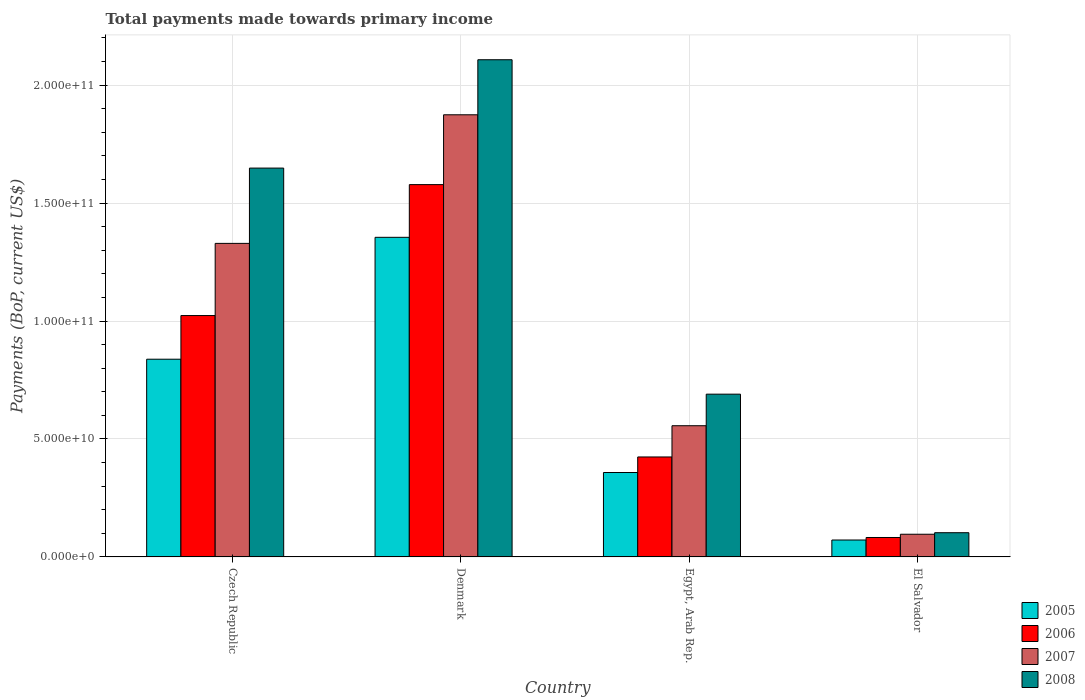How many groups of bars are there?
Your response must be concise. 4. How many bars are there on the 2nd tick from the right?
Your answer should be compact. 4. What is the label of the 1st group of bars from the left?
Offer a terse response. Czech Republic. What is the total payments made towards primary income in 2008 in Egypt, Arab Rep.?
Your answer should be compact. 6.90e+1. Across all countries, what is the maximum total payments made towards primary income in 2008?
Provide a short and direct response. 2.11e+11. Across all countries, what is the minimum total payments made towards primary income in 2008?
Ensure brevity in your answer.  1.03e+1. In which country was the total payments made towards primary income in 2007 maximum?
Make the answer very short. Denmark. In which country was the total payments made towards primary income in 2007 minimum?
Provide a short and direct response. El Salvador. What is the total total payments made towards primary income in 2007 in the graph?
Provide a short and direct response. 3.86e+11. What is the difference between the total payments made towards primary income in 2007 in Czech Republic and that in Denmark?
Keep it short and to the point. -5.45e+1. What is the difference between the total payments made towards primary income in 2008 in Egypt, Arab Rep. and the total payments made towards primary income in 2006 in El Salvador?
Ensure brevity in your answer.  6.08e+1. What is the average total payments made towards primary income in 2007 per country?
Give a very brief answer. 9.64e+1. What is the difference between the total payments made towards primary income of/in 2006 and total payments made towards primary income of/in 2007 in Czech Republic?
Give a very brief answer. -3.06e+1. In how many countries, is the total payments made towards primary income in 2008 greater than 70000000000 US$?
Your answer should be very brief. 2. What is the ratio of the total payments made towards primary income in 2005 in Czech Republic to that in Egypt, Arab Rep.?
Your answer should be compact. 2.34. What is the difference between the highest and the second highest total payments made towards primary income in 2006?
Offer a very short reply. -1.15e+11. What is the difference between the highest and the lowest total payments made towards primary income in 2007?
Your answer should be very brief. 1.78e+11. Is it the case that in every country, the sum of the total payments made towards primary income in 2006 and total payments made towards primary income in 2007 is greater than the sum of total payments made towards primary income in 2008 and total payments made towards primary income in 2005?
Provide a succinct answer. No. Is it the case that in every country, the sum of the total payments made towards primary income in 2005 and total payments made towards primary income in 2008 is greater than the total payments made towards primary income in 2006?
Provide a short and direct response. Yes. How many bars are there?
Offer a very short reply. 16. Are all the bars in the graph horizontal?
Provide a succinct answer. No. What is the difference between two consecutive major ticks on the Y-axis?
Offer a terse response. 5.00e+1. How many legend labels are there?
Make the answer very short. 4. What is the title of the graph?
Give a very brief answer. Total payments made towards primary income. What is the label or title of the Y-axis?
Your response must be concise. Payments (BoP, current US$). What is the Payments (BoP, current US$) in 2005 in Czech Republic?
Offer a very short reply. 8.38e+1. What is the Payments (BoP, current US$) in 2006 in Czech Republic?
Keep it short and to the point. 1.02e+11. What is the Payments (BoP, current US$) in 2007 in Czech Republic?
Your answer should be compact. 1.33e+11. What is the Payments (BoP, current US$) in 2008 in Czech Republic?
Provide a succinct answer. 1.65e+11. What is the Payments (BoP, current US$) in 2005 in Denmark?
Your answer should be very brief. 1.35e+11. What is the Payments (BoP, current US$) in 2006 in Denmark?
Offer a terse response. 1.58e+11. What is the Payments (BoP, current US$) in 2007 in Denmark?
Offer a very short reply. 1.87e+11. What is the Payments (BoP, current US$) of 2008 in Denmark?
Provide a short and direct response. 2.11e+11. What is the Payments (BoP, current US$) of 2005 in Egypt, Arab Rep.?
Give a very brief answer. 3.58e+1. What is the Payments (BoP, current US$) of 2006 in Egypt, Arab Rep.?
Ensure brevity in your answer.  4.24e+1. What is the Payments (BoP, current US$) in 2007 in Egypt, Arab Rep.?
Your answer should be very brief. 5.56e+1. What is the Payments (BoP, current US$) of 2008 in Egypt, Arab Rep.?
Offer a terse response. 6.90e+1. What is the Payments (BoP, current US$) in 2005 in El Salvador?
Your response must be concise. 7.17e+09. What is the Payments (BoP, current US$) in 2006 in El Salvador?
Provide a succinct answer. 8.24e+09. What is the Payments (BoP, current US$) of 2007 in El Salvador?
Ensure brevity in your answer.  9.62e+09. What is the Payments (BoP, current US$) of 2008 in El Salvador?
Offer a terse response. 1.03e+1. Across all countries, what is the maximum Payments (BoP, current US$) in 2005?
Your answer should be very brief. 1.35e+11. Across all countries, what is the maximum Payments (BoP, current US$) of 2006?
Offer a very short reply. 1.58e+11. Across all countries, what is the maximum Payments (BoP, current US$) in 2007?
Give a very brief answer. 1.87e+11. Across all countries, what is the maximum Payments (BoP, current US$) of 2008?
Your response must be concise. 2.11e+11. Across all countries, what is the minimum Payments (BoP, current US$) of 2005?
Offer a terse response. 7.17e+09. Across all countries, what is the minimum Payments (BoP, current US$) in 2006?
Your response must be concise. 8.24e+09. Across all countries, what is the minimum Payments (BoP, current US$) of 2007?
Offer a terse response. 9.62e+09. Across all countries, what is the minimum Payments (BoP, current US$) of 2008?
Make the answer very short. 1.03e+1. What is the total Payments (BoP, current US$) in 2005 in the graph?
Provide a succinct answer. 2.62e+11. What is the total Payments (BoP, current US$) of 2006 in the graph?
Make the answer very short. 3.11e+11. What is the total Payments (BoP, current US$) in 2007 in the graph?
Keep it short and to the point. 3.86e+11. What is the total Payments (BoP, current US$) in 2008 in the graph?
Your response must be concise. 4.55e+11. What is the difference between the Payments (BoP, current US$) in 2005 in Czech Republic and that in Denmark?
Provide a succinct answer. -5.17e+1. What is the difference between the Payments (BoP, current US$) of 2006 in Czech Republic and that in Denmark?
Your answer should be compact. -5.55e+1. What is the difference between the Payments (BoP, current US$) of 2007 in Czech Republic and that in Denmark?
Keep it short and to the point. -5.45e+1. What is the difference between the Payments (BoP, current US$) in 2008 in Czech Republic and that in Denmark?
Offer a very short reply. -4.59e+1. What is the difference between the Payments (BoP, current US$) of 2005 in Czech Republic and that in Egypt, Arab Rep.?
Your answer should be very brief. 4.80e+1. What is the difference between the Payments (BoP, current US$) of 2006 in Czech Republic and that in Egypt, Arab Rep.?
Your response must be concise. 5.99e+1. What is the difference between the Payments (BoP, current US$) of 2007 in Czech Republic and that in Egypt, Arab Rep.?
Offer a very short reply. 7.73e+1. What is the difference between the Payments (BoP, current US$) of 2008 in Czech Republic and that in Egypt, Arab Rep.?
Provide a succinct answer. 9.58e+1. What is the difference between the Payments (BoP, current US$) of 2005 in Czech Republic and that in El Salvador?
Your response must be concise. 7.66e+1. What is the difference between the Payments (BoP, current US$) of 2006 in Czech Republic and that in El Salvador?
Keep it short and to the point. 9.41e+1. What is the difference between the Payments (BoP, current US$) in 2007 in Czech Republic and that in El Salvador?
Ensure brevity in your answer.  1.23e+11. What is the difference between the Payments (BoP, current US$) of 2008 in Czech Republic and that in El Salvador?
Your response must be concise. 1.55e+11. What is the difference between the Payments (BoP, current US$) of 2005 in Denmark and that in Egypt, Arab Rep.?
Offer a very short reply. 9.97e+1. What is the difference between the Payments (BoP, current US$) in 2006 in Denmark and that in Egypt, Arab Rep.?
Give a very brief answer. 1.15e+11. What is the difference between the Payments (BoP, current US$) in 2007 in Denmark and that in Egypt, Arab Rep.?
Keep it short and to the point. 1.32e+11. What is the difference between the Payments (BoP, current US$) in 2008 in Denmark and that in Egypt, Arab Rep.?
Ensure brevity in your answer.  1.42e+11. What is the difference between the Payments (BoP, current US$) in 2005 in Denmark and that in El Salvador?
Your answer should be compact. 1.28e+11. What is the difference between the Payments (BoP, current US$) of 2006 in Denmark and that in El Salvador?
Ensure brevity in your answer.  1.50e+11. What is the difference between the Payments (BoP, current US$) in 2007 in Denmark and that in El Salvador?
Your response must be concise. 1.78e+11. What is the difference between the Payments (BoP, current US$) of 2008 in Denmark and that in El Salvador?
Offer a very short reply. 2.01e+11. What is the difference between the Payments (BoP, current US$) in 2005 in Egypt, Arab Rep. and that in El Salvador?
Keep it short and to the point. 2.86e+1. What is the difference between the Payments (BoP, current US$) of 2006 in Egypt, Arab Rep. and that in El Salvador?
Offer a terse response. 3.41e+1. What is the difference between the Payments (BoP, current US$) in 2007 in Egypt, Arab Rep. and that in El Salvador?
Make the answer very short. 4.60e+1. What is the difference between the Payments (BoP, current US$) in 2008 in Egypt, Arab Rep. and that in El Salvador?
Your answer should be compact. 5.87e+1. What is the difference between the Payments (BoP, current US$) in 2005 in Czech Republic and the Payments (BoP, current US$) in 2006 in Denmark?
Your answer should be compact. -7.40e+1. What is the difference between the Payments (BoP, current US$) in 2005 in Czech Republic and the Payments (BoP, current US$) in 2007 in Denmark?
Ensure brevity in your answer.  -1.04e+11. What is the difference between the Payments (BoP, current US$) in 2005 in Czech Republic and the Payments (BoP, current US$) in 2008 in Denmark?
Provide a succinct answer. -1.27e+11. What is the difference between the Payments (BoP, current US$) of 2006 in Czech Republic and the Payments (BoP, current US$) of 2007 in Denmark?
Offer a very short reply. -8.51e+1. What is the difference between the Payments (BoP, current US$) in 2006 in Czech Republic and the Payments (BoP, current US$) in 2008 in Denmark?
Offer a very short reply. -1.08e+11. What is the difference between the Payments (BoP, current US$) of 2007 in Czech Republic and the Payments (BoP, current US$) of 2008 in Denmark?
Provide a short and direct response. -7.78e+1. What is the difference between the Payments (BoP, current US$) of 2005 in Czech Republic and the Payments (BoP, current US$) of 2006 in Egypt, Arab Rep.?
Provide a short and direct response. 4.14e+1. What is the difference between the Payments (BoP, current US$) in 2005 in Czech Republic and the Payments (BoP, current US$) in 2007 in Egypt, Arab Rep.?
Give a very brief answer. 2.82e+1. What is the difference between the Payments (BoP, current US$) of 2005 in Czech Republic and the Payments (BoP, current US$) of 2008 in Egypt, Arab Rep.?
Your response must be concise. 1.48e+1. What is the difference between the Payments (BoP, current US$) in 2006 in Czech Republic and the Payments (BoP, current US$) in 2007 in Egypt, Arab Rep.?
Your answer should be very brief. 4.67e+1. What is the difference between the Payments (BoP, current US$) of 2006 in Czech Republic and the Payments (BoP, current US$) of 2008 in Egypt, Arab Rep.?
Provide a short and direct response. 3.33e+1. What is the difference between the Payments (BoP, current US$) of 2007 in Czech Republic and the Payments (BoP, current US$) of 2008 in Egypt, Arab Rep.?
Provide a short and direct response. 6.39e+1. What is the difference between the Payments (BoP, current US$) of 2005 in Czech Republic and the Payments (BoP, current US$) of 2006 in El Salvador?
Offer a terse response. 7.56e+1. What is the difference between the Payments (BoP, current US$) of 2005 in Czech Republic and the Payments (BoP, current US$) of 2007 in El Salvador?
Keep it short and to the point. 7.42e+1. What is the difference between the Payments (BoP, current US$) of 2005 in Czech Republic and the Payments (BoP, current US$) of 2008 in El Salvador?
Ensure brevity in your answer.  7.35e+1. What is the difference between the Payments (BoP, current US$) of 2006 in Czech Republic and the Payments (BoP, current US$) of 2007 in El Salvador?
Offer a very short reply. 9.27e+1. What is the difference between the Payments (BoP, current US$) of 2006 in Czech Republic and the Payments (BoP, current US$) of 2008 in El Salvador?
Offer a very short reply. 9.21e+1. What is the difference between the Payments (BoP, current US$) of 2007 in Czech Republic and the Payments (BoP, current US$) of 2008 in El Salvador?
Provide a succinct answer. 1.23e+11. What is the difference between the Payments (BoP, current US$) in 2005 in Denmark and the Payments (BoP, current US$) in 2006 in Egypt, Arab Rep.?
Provide a succinct answer. 9.31e+1. What is the difference between the Payments (BoP, current US$) of 2005 in Denmark and the Payments (BoP, current US$) of 2007 in Egypt, Arab Rep.?
Offer a terse response. 7.99e+1. What is the difference between the Payments (BoP, current US$) in 2005 in Denmark and the Payments (BoP, current US$) in 2008 in Egypt, Arab Rep.?
Give a very brief answer. 6.65e+1. What is the difference between the Payments (BoP, current US$) in 2006 in Denmark and the Payments (BoP, current US$) in 2007 in Egypt, Arab Rep.?
Offer a terse response. 1.02e+11. What is the difference between the Payments (BoP, current US$) in 2006 in Denmark and the Payments (BoP, current US$) in 2008 in Egypt, Arab Rep.?
Keep it short and to the point. 8.88e+1. What is the difference between the Payments (BoP, current US$) in 2007 in Denmark and the Payments (BoP, current US$) in 2008 in Egypt, Arab Rep.?
Give a very brief answer. 1.18e+11. What is the difference between the Payments (BoP, current US$) in 2005 in Denmark and the Payments (BoP, current US$) in 2006 in El Salvador?
Your answer should be very brief. 1.27e+11. What is the difference between the Payments (BoP, current US$) of 2005 in Denmark and the Payments (BoP, current US$) of 2007 in El Salvador?
Offer a terse response. 1.26e+11. What is the difference between the Payments (BoP, current US$) of 2005 in Denmark and the Payments (BoP, current US$) of 2008 in El Salvador?
Provide a succinct answer. 1.25e+11. What is the difference between the Payments (BoP, current US$) of 2006 in Denmark and the Payments (BoP, current US$) of 2007 in El Salvador?
Provide a succinct answer. 1.48e+11. What is the difference between the Payments (BoP, current US$) of 2006 in Denmark and the Payments (BoP, current US$) of 2008 in El Salvador?
Ensure brevity in your answer.  1.48e+11. What is the difference between the Payments (BoP, current US$) in 2007 in Denmark and the Payments (BoP, current US$) in 2008 in El Salvador?
Provide a short and direct response. 1.77e+11. What is the difference between the Payments (BoP, current US$) in 2005 in Egypt, Arab Rep. and the Payments (BoP, current US$) in 2006 in El Salvador?
Ensure brevity in your answer.  2.75e+1. What is the difference between the Payments (BoP, current US$) of 2005 in Egypt, Arab Rep. and the Payments (BoP, current US$) of 2007 in El Salvador?
Provide a succinct answer. 2.62e+1. What is the difference between the Payments (BoP, current US$) in 2005 in Egypt, Arab Rep. and the Payments (BoP, current US$) in 2008 in El Salvador?
Provide a succinct answer. 2.55e+1. What is the difference between the Payments (BoP, current US$) in 2006 in Egypt, Arab Rep. and the Payments (BoP, current US$) in 2007 in El Salvador?
Provide a succinct answer. 3.28e+1. What is the difference between the Payments (BoP, current US$) in 2006 in Egypt, Arab Rep. and the Payments (BoP, current US$) in 2008 in El Salvador?
Offer a terse response. 3.21e+1. What is the difference between the Payments (BoP, current US$) in 2007 in Egypt, Arab Rep. and the Payments (BoP, current US$) in 2008 in El Salvador?
Your response must be concise. 4.53e+1. What is the average Payments (BoP, current US$) of 2005 per country?
Make the answer very short. 6.56e+1. What is the average Payments (BoP, current US$) in 2006 per country?
Provide a succinct answer. 7.77e+1. What is the average Payments (BoP, current US$) of 2007 per country?
Offer a terse response. 9.64e+1. What is the average Payments (BoP, current US$) in 2008 per country?
Offer a terse response. 1.14e+11. What is the difference between the Payments (BoP, current US$) of 2005 and Payments (BoP, current US$) of 2006 in Czech Republic?
Provide a short and direct response. -1.85e+1. What is the difference between the Payments (BoP, current US$) of 2005 and Payments (BoP, current US$) of 2007 in Czech Republic?
Provide a short and direct response. -4.91e+1. What is the difference between the Payments (BoP, current US$) of 2005 and Payments (BoP, current US$) of 2008 in Czech Republic?
Make the answer very short. -8.10e+1. What is the difference between the Payments (BoP, current US$) of 2006 and Payments (BoP, current US$) of 2007 in Czech Republic?
Give a very brief answer. -3.06e+1. What is the difference between the Payments (BoP, current US$) in 2006 and Payments (BoP, current US$) in 2008 in Czech Republic?
Make the answer very short. -6.25e+1. What is the difference between the Payments (BoP, current US$) of 2007 and Payments (BoP, current US$) of 2008 in Czech Republic?
Offer a terse response. -3.19e+1. What is the difference between the Payments (BoP, current US$) in 2005 and Payments (BoP, current US$) in 2006 in Denmark?
Provide a succinct answer. -2.23e+1. What is the difference between the Payments (BoP, current US$) of 2005 and Payments (BoP, current US$) of 2007 in Denmark?
Offer a terse response. -5.19e+1. What is the difference between the Payments (BoP, current US$) of 2005 and Payments (BoP, current US$) of 2008 in Denmark?
Make the answer very short. -7.53e+1. What is the difference between the Payments (BoP, current US$) in 2006 and Payments (BoP, current US$) in 2007 in Denmark?
Your answer should be compact. -2.96e+1. What is the difference between the Payments (BoP, current US$) in 2006 and Payments (BoP, current US$) in 2008 in Denmark?
Keep it short and to the point. -5.29e+1. What is the difference between the Payments (BoP, current US$) of 2007 and Payments (BoP, current US$) of 2008 in Denmark?
Provide a succinct answer. -2.33e+1. What is the difference between the Payments (BoP, current US$) in 2005 and Payments (BoP, current US$) in 2006 in Egypt, Arab Rep.?
Make the answer very short. -6.59e+09. What is the difference between the Payments (BoP, current US$) of 2005 and Payments (BoP, current US$) of 2007 in Egypt, Arab Rep.?
Keep it short and to the point. -1.98e+1. What is the difference between the Payments (BoP, current US$) of 2005 and Payments (BoP, current US$) of 2008 in Egypt, Arab Rep.?
Offer a very short reply. -3.32e+1. What is the difference between the Payments (BoP, current US$) in 2006 and Payments (BoP, current US$) in 2007 in Egypt, Arab Rep.?
Offer a very short reply. -1.32e+1. What is the difference between the Payments (BoP, current US$) in 2006 and Payments (BoP, current US$) in 2008 in Egypt, Arab Rep.?
Keep it short and to the point. -2.66e+1. What is the difference between the Payments (BoP, current US$) of 2007 and Payments (BoP, current US$) of 2008 in Egypt, Arab Rep.?
Your answer should be very brief. -1.34e+1. What is the difference between the Payments (BoP, current US$) in 2005 and Payments (BoP, current US$) in 2006 in El Salvador?
Offer a very short reply. -1.07e+09. What is the difference between the Payments (BoP, current US$) in 2005 and Payments (BoP, current US$) in 2007 in El Salvador?
Ensure brevity in your answer.  -2.45e+09. What is the difference between the Payments (BoP, current US$) in 2005 and Payments (BoP, current US$) in 2008 in El Salvador?
Give a very brief answer. -3.09e+09. What is the difference between the Payments (BoP, current US$) in 2006 and Payments (BoP, current US$) in 2007 in El Salvador?
Ensure brevity in your answer.  -1.38e+09. What is the difference between the Payments (BoP, current US$) in 2006 and Payments (BoP, current US$) in 2008 in El Salvador?
Make the answer very short. -2.03e+09. What is the difference between the Payments (BoP, current US$) of 2007 and Payments (BoP, current US$) of 2008 in El Salvador?
Make the answer very short. -6.48e+08. What is the ratio of the Payments (BoP, current US$) of 2005 in Czech Republic to that in Denmark?
Make the answer very short. 0.62. What is the ratio of the Payments (BoP, current US$) of 2006 in Czech Republic to that in Denmark?
Provide a short and direct response. 0.65. What is the ratio of the Payments (BoP, current US$) of 2007 in Czech Republic to that in Denmark?
Make the answer very short. 0.71. What is the ratio of the Payments (BoP, current US$) of 2008 in Czech Republic to that in Denmark?
Offer a very short reply. 0.78. What is the ratio of the Payments (BoP, current US$) of 2005 in Czech Republic to that in Egypt, Arab Rep.?
Make the answer very short. 2.34. What is the ratio of the Payments (BoP, current US$) of 2006 in Czech Republic to that in Egypt, Arab Rep.?
Offer a very short reply. 2.41. What is the ratio of the Payments (BoP, current US$) in 2007 in Czech Republic to that in Egypt, Arab Rep.?
Provide a short and direct response. 2.39. What is the ratio of the Payments (BoP, current US$) of 2008 in Czech Republic to that in Egypt, Arab Rep.?
Your response must be concise. 2.39. What is the ratio of the Payments (BoP, current US$) of 2005 in Czech Republic to that in El Salvador?
Keep it short and to the point. 11.68. What is the ratio of the Payments (BoP, current US$) in 2006 in Czech Republic to that in El Salvador?
Your response must be concise. 12.41. What is the ratio of the Payments (BoP, current US$) in 2007 in Czech Republic to that in El Salvador?
Your answer should be very brief. 13.82. What is the ratio of the Payments (BoP, current US$) in 2008 in Czech Republic to that in El Salvador?
Offer a terse response. 16.05. What is the ratio of the Payments (BoP, current US$) in 2005 in Denmark to that in Egypt, Arab Rep.?
Provide a short and direct response. 3.79. What is the ratio of the Payments (BoP, current US$) in 2006 in Denmark to that in Egypt, Arab Rep.?
Provide a succinct answer. 3.72. What is the ratio of the Payments (BoP, current US$) of 2007 in Denmark to that in Egypt, Arab Rep.?
Provide a succinct answer. 3.37. What is the ratio of the Payments (BoP, current US$) in 2008 in Denmark to that in Egypt, Arab Rep.?
Offer a terse response. 3.05. What is the ratio of the Payments (BoP, current US$) in 2005 in Denmark to that in El Salvador?
Your answer should be very brief. 18.89. What is the ratio of the Payments (BoP, current US$) in 2006 in Denmark to that in El Salvador?
Offer a very short reply. 19.15. What is the ratio of the Payments (BoP, current US$) of 2007 in Denmark to that in El Salvador?
Your answer should be very brief. 19.48. What is the ratio of the Payments (BoP, current US$) of 2008 in Denmark to that in El Salvador?
Give a very brief answer. 20.53. What is the ratio of the Payments (BoP, current US$) in 2005 in Egypt, Arab Rep. to that in El Salvador?
Ensure brevity in your answer.  4.99. What is the ratio of the Payments (BoP, current US$) in 2006 in Egypt, Arab Rep. to that in El Salvador?
Give a very brief answer. 5.14. What is the ratio of the Payments (BoP, current US$) of 2007 in Egypt, Arab Rep. to that in El Salvador?
Give a very brief answer. 5.78. What is the ratio of the Payments (BoP, current US$) of 2008 in Egypt, Arab Rep. to that in El Salvador?
Ensure brevity in your answer.  6.72. What is the difference between the highest and the second highest Payments (BoP, current US$) in 2005?
Give a very brief answer. 5.17e+1. What is the difference between the highest and the second highest Payments (BoP, current US$) of 2006?
Your response must be concise. 5.55e+1. What is the difference between the highest and the second highest Payments (BoP, current US$) of 2007?
Provide a succinct answer. 5.45e+1. What is the difference between the highest and the second highest Payments (BoP, current US$) in 2008?
Provide a succinct answer. 4.59e+1. What is the difference between the highest and the lowest Payments (BoP, current US$) in 2005?
Keep it short and to the point. 1.28e+11. What is the difference between the highest and the lowest Payments (BoP, current US$) of 2006?
Make the answer very short. 1.50e+11. What is the difference between the highest and the lowest Payments (BoP, current US$) of 2007?
Your response must be concise. 1.78e+11. What is the difference between the highest and the lowest Payments (BoP, current US$) of 2008?
Your response must be concise. 2.01e+11. 